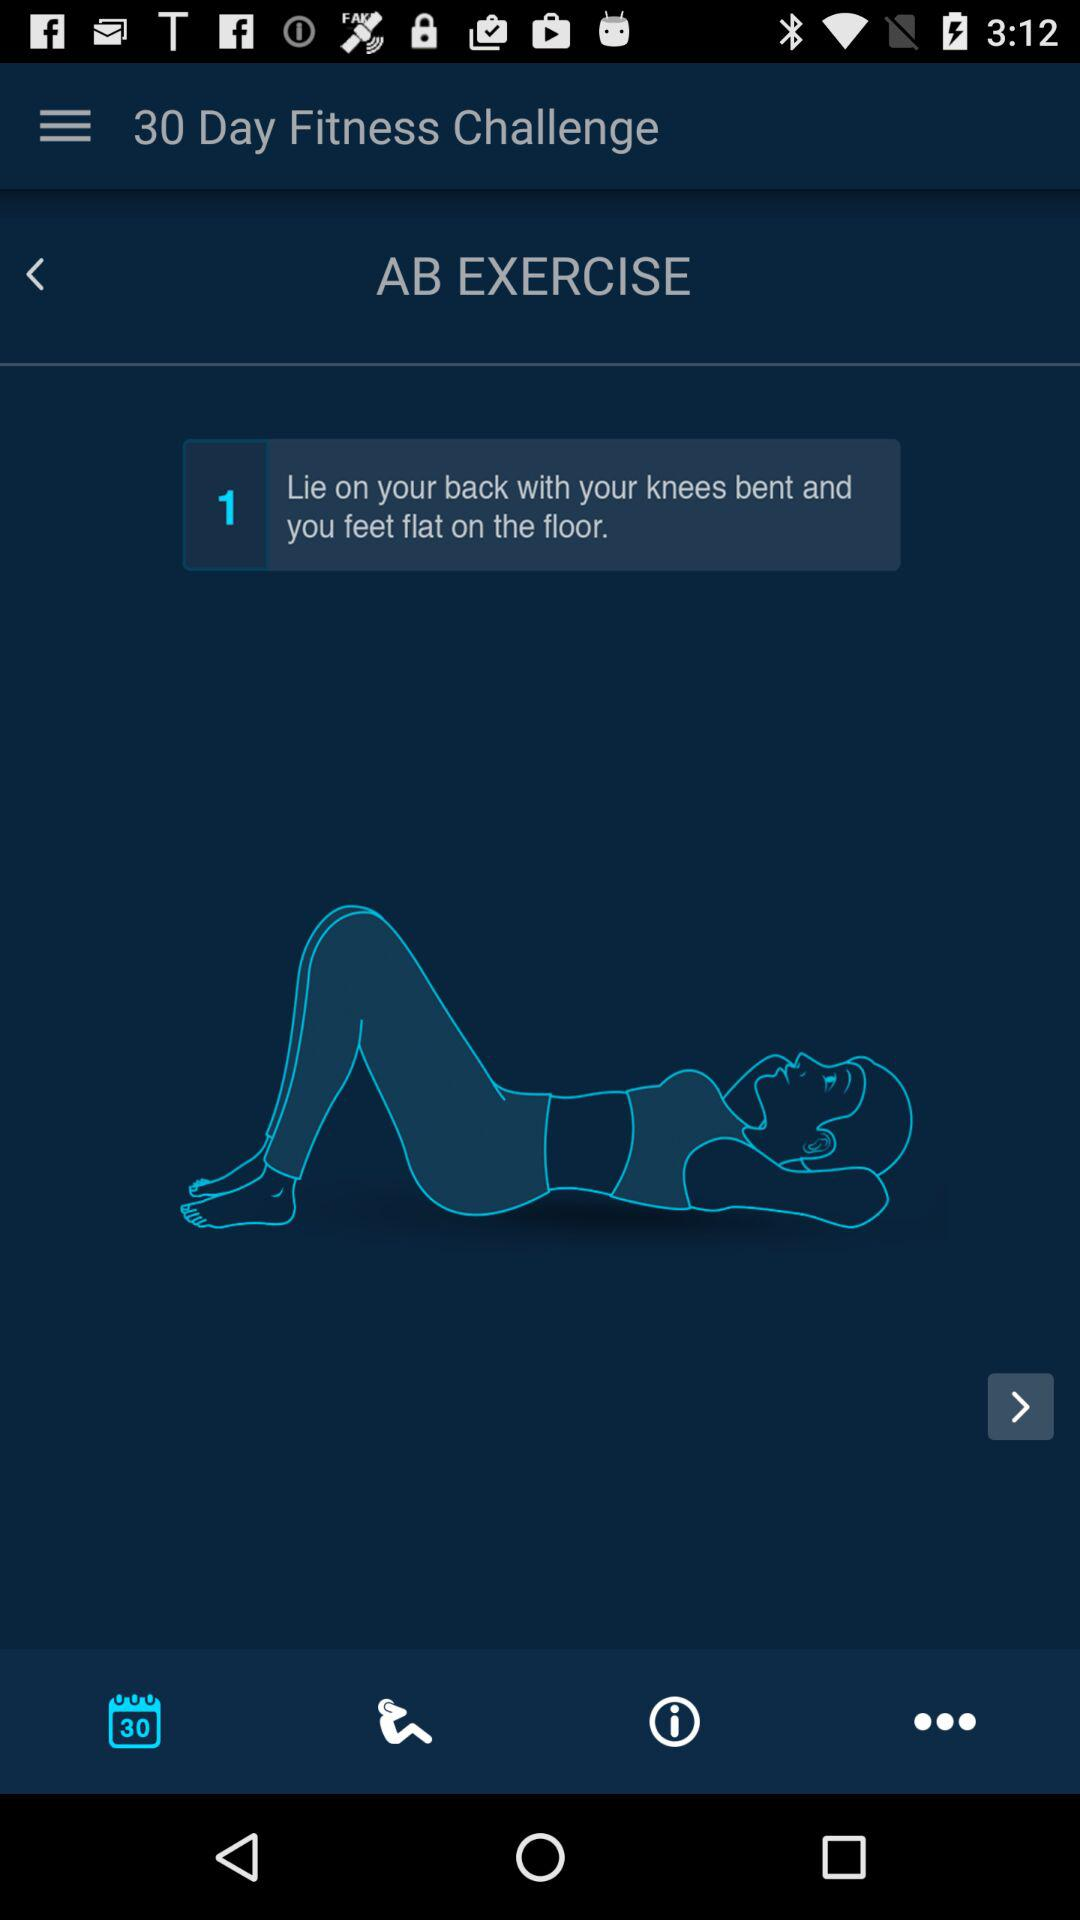How many steps are there in this exercise?
Answer the question using a single word or phrase. 1 